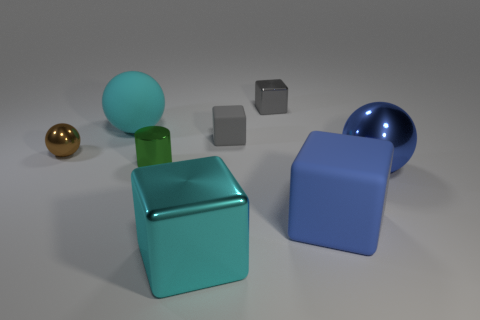Subtract 1 cubes. How many cubes are left? 3 Add 1 tiny red matte spheres. How many objects exist? 9 Subtract all cylinders. How many objects are left? 7 Add 7 tiny green metallic cylinders. How many tiny green metallic cylinders are left? 8 Add 1 big red shiny cylinders. How many big red shiny cylinders exist? 1 Subtract 0 yellow blocks. How many objects are left? 8 Subtract all tiny gray things. Subtract all large cyan metallic things. How many objects are left? 5 